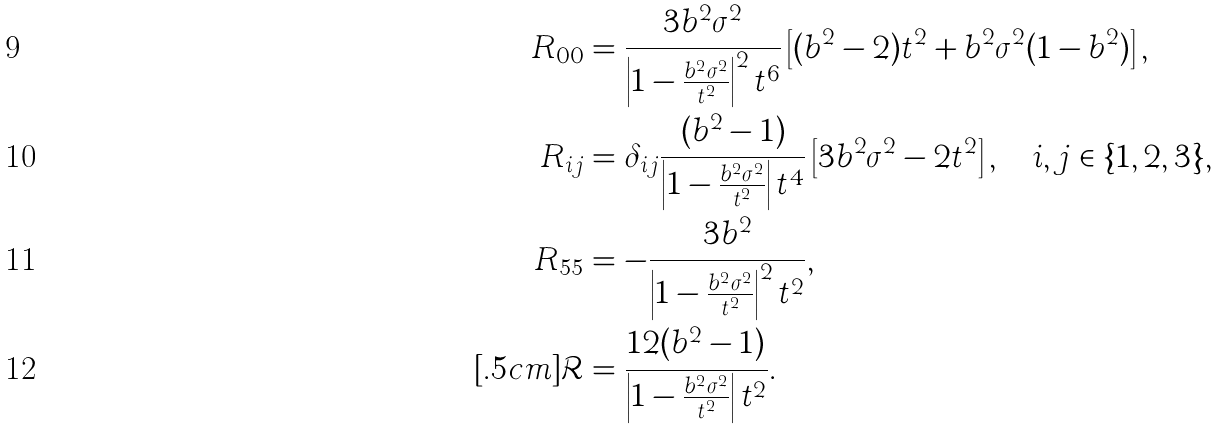Convert formula to latex. <formula><loc_0><loc_0><loc_500><loc_500>R _ { 0 0 } & = \frac { 3 b ^ { 2 } \sigma ^ { 2 } } { \left | 1 - \frac { b ^ { 2 } \sigma ^ { 2 } } { t ^ { 2 } } \right | ^ { 2 } t ^ { 6 } } \left [ ( b ^ { 2 } - 2 ) t ^ { 2 } + b ^ { 2 } \sigma ^ { 2 } ( 1 - b ^ { 2 } ) \right ] , \\ R _ { i j } & = \delta _ { i j } \frac { ( b ^ { 2 } - 1 ) } { \left | 1 - \frac { b ^ { 2 } \sigma ^ { 2 } } { t ^ { 2 } } \right | t ^ { 4 } } \left [ 3 b ^ { 2 } \sigma ^ { 2 } - 2 t ^ { 2 } \right ] , \quad i , j \in \{ 1 , 2 , 3 \} , \\ R _ { 5 5 } & = - \frac { 3 b ^ { 2 } } { \left | 1 - \frac { b ^ { 2 } \sigma ^ { 2 } } { t ^ { 2 } } \right | ^ { 2 } t ^ { 2 } } , \\ [ . 5 c m ] \mathcal { R } & = \frac { 1 2 ( b ^ { 2 } - 1 ) } { \left | 1 - \frac { b ^ { 2 } \sigma ^ { 2 } } { t ^ { 2 } } \right | t ^ { 2 } } .</formula> 